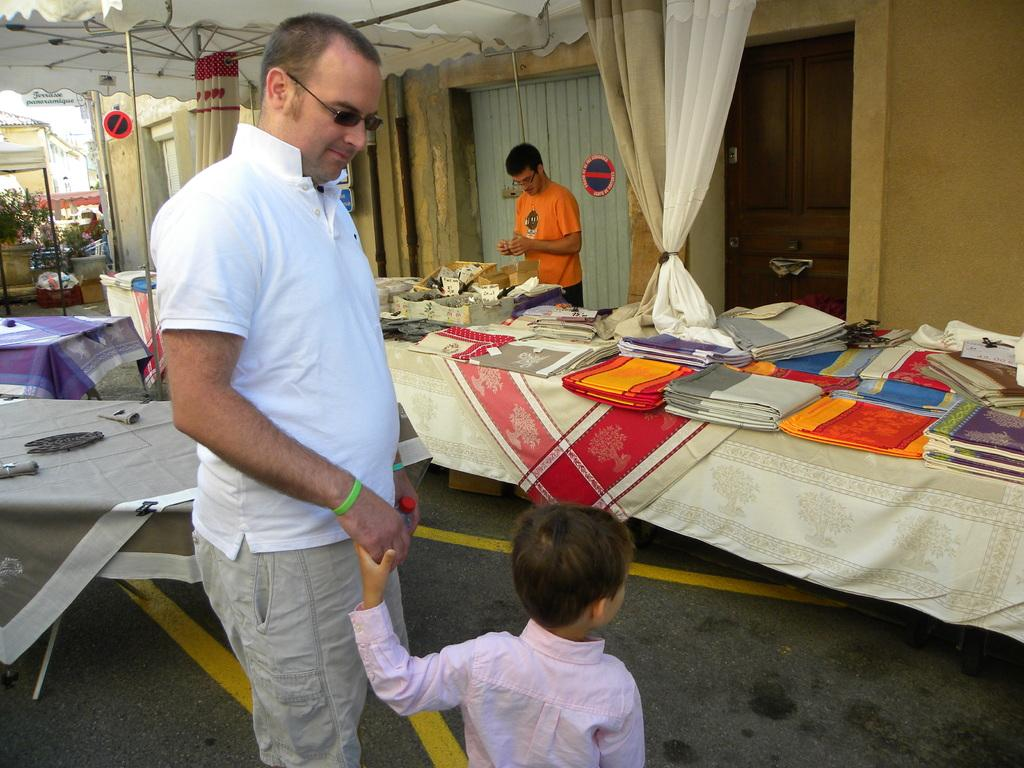How many people are present in the image? There are two people in the image, a man and a boy. What are the man and the boy doing in the image? The man and the boy are standing. What can be seen on the table in the image? There are clothes on a table in the image. Are there any other people in the image besides the man and the boy? Yes, there is another man standing in the image. What type of yard can be seen in the image? There is no yard visible in the image. Is the mom of the boy in the image? There is no indication of the boy's mom being present in the image. 